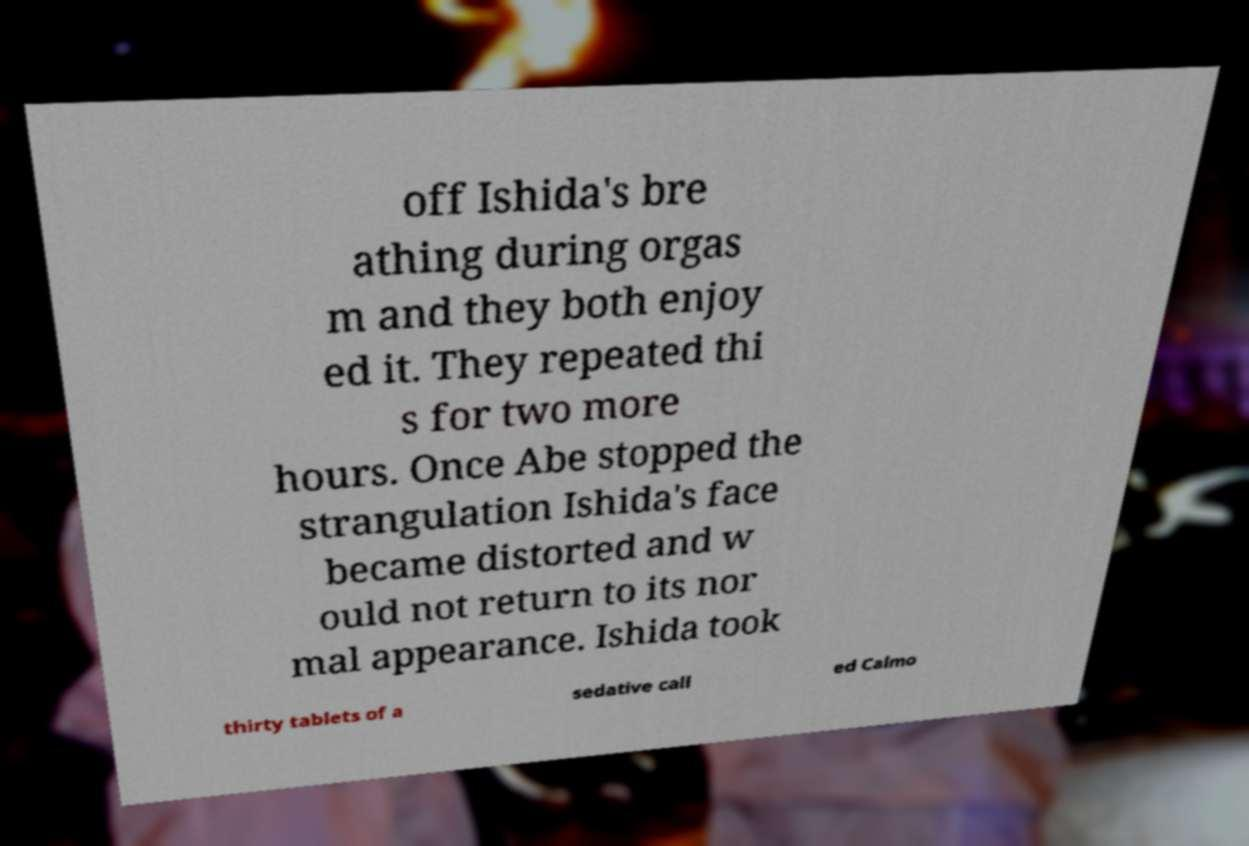What messages or text are displayed in this image? I need them in a readable, typed format. off Ishida's bre athing during orgas m and they both enjoy ed it. They repeated thi s for two more hours. Once Abe stopped the strangulation Ishida's face became distorted and w ould not return to its nor mal appearance. Ishida took thirty tablets of a sedative call ed Calmo 